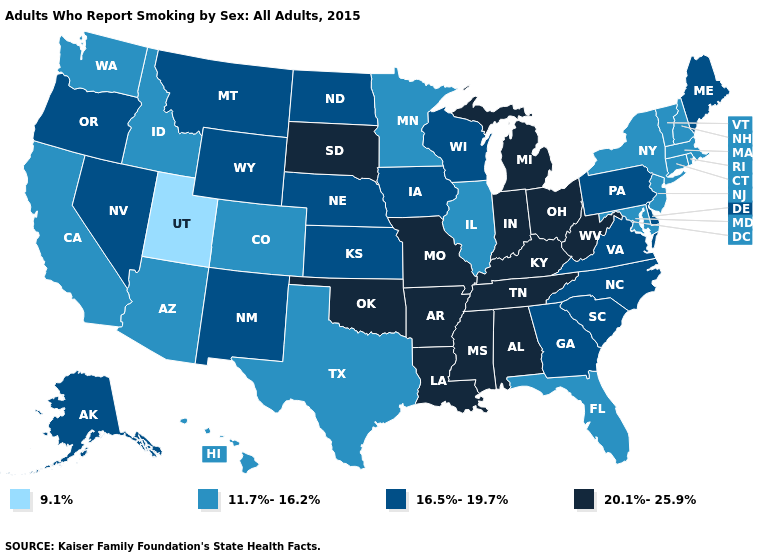Does Oklahoma have the highest value in the USA?
Be succinct. Yes. Name the states that have a value in the range 9.1%?
Quick response, please. Utah. Name the states that have a value in the range 9.1%?
Give a very brief answer. Utah. Name the states that have a value in the range 9.1%?
Give a very brief answer. Utah. Does Maryland have the lowest value in the South?
Be succinct. Yes. What is the highest value in the USA?
Keep it brief. 20.1%-25.9%. Among the states that border Wisconsin , which have the lowest value?
Quick response, please. Illinois, Minnesota. Name the states that have a value in the range 11.7%-16.2%?
Be succinct. Arizona, California, Colorado, Connecticut, Florida, Hawaii, Idaho, Illinois, Maryland, Massachusetts, Minnesota, New Hampshire, New Jersey, New York, Rhode Island, Texas, Vermont, Washington. Does North Dakota have the same value as New Jersey?
Write a very short answer. No. Does Maine have the lowest value in the Northeast?
Write a very short answer. No. Does Ohio have the lowest value in the USA?
Answer briefly. No. Which states have the lowest value in the South?
Keep it brief. Florida, Maryland, Texas. Does the first symbol in the legend represent the smallest category?
Give a very brief answer. Yes. What is the value of Louisiana?
Keep it brief. 20.1%-25.9%. Which states hav the highest value in the South?
Short answer required. Alabama, Arkansas, Kentucky, Louisiana, Mississippi, Oklahoma, Tennessee, West Virginia. 